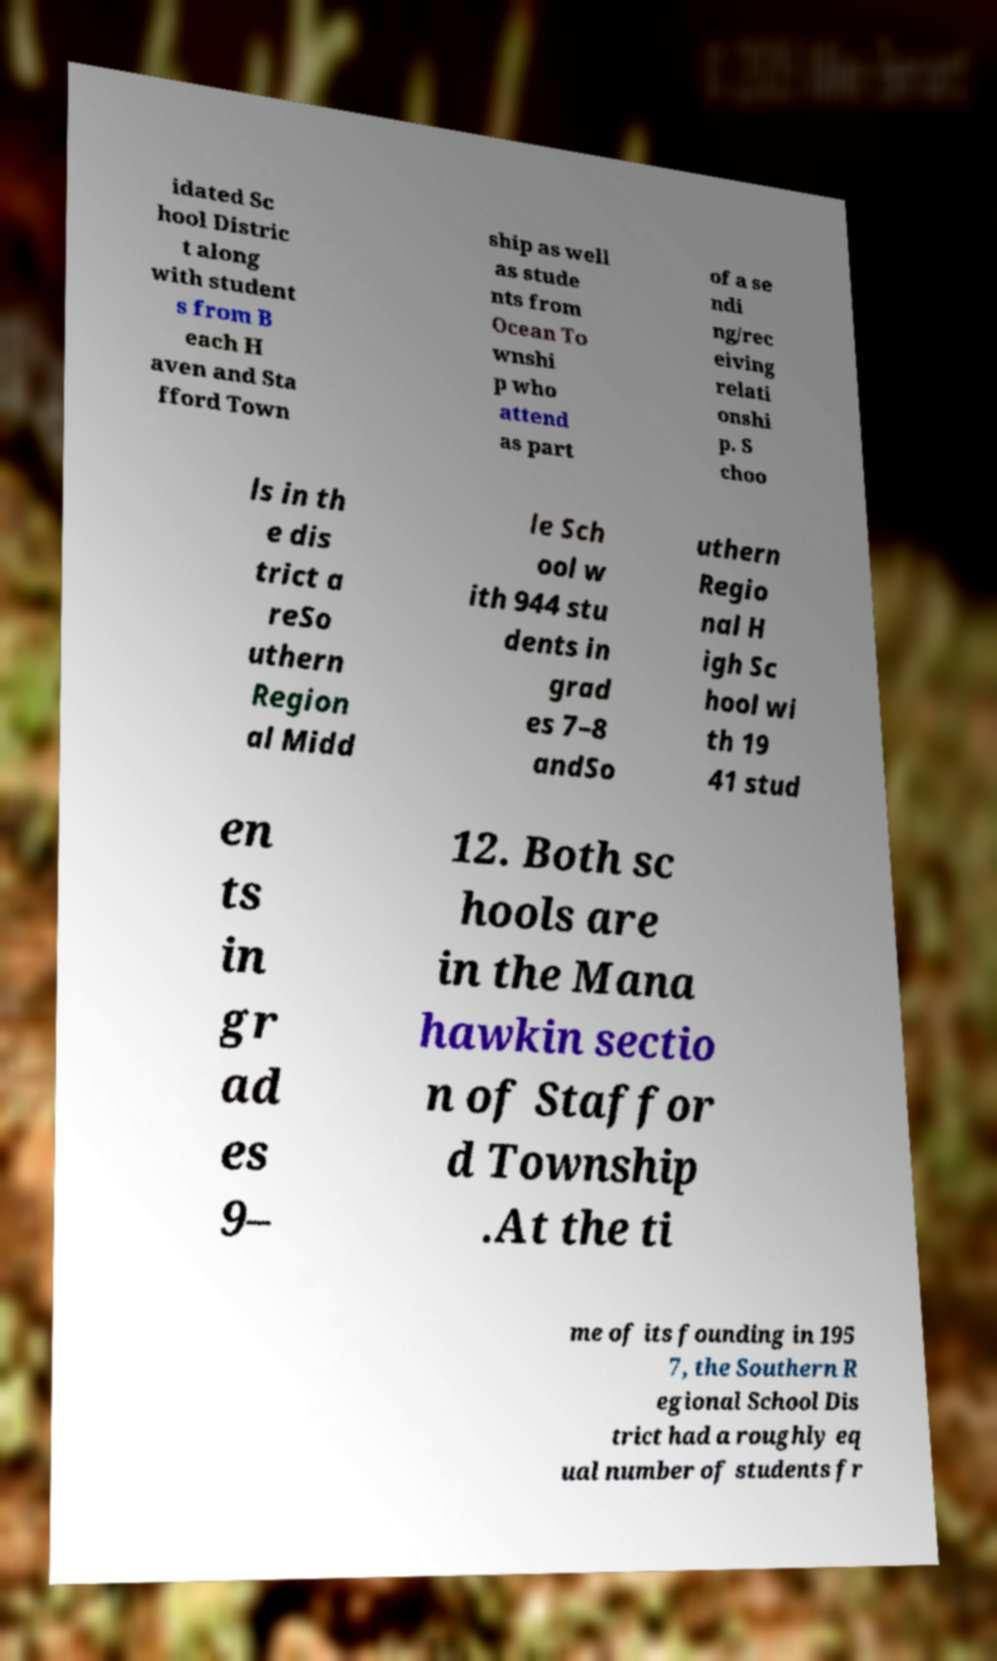Can you accurately transcribe the text from the provided image for me? idated Sc hool Distric t along with student s from B each H aven and Sta fford Town ship as well as stude nts from Ocean To wnshi p who attend as part of a se ndi ng/rec eiving relati onshi p. S choo ls in th e dis trict a reSo uthern Region al Midd le Sch ool w ith 944 stu dents in grad es 7–8 andSo uthern Regio nal H igh Sc hool wi th 19 41 stud en ts in gr ad es 9– 12. Both sc hools are in the Mana hawkin sectio n of Staffor d Township .At the ti me of its founding in 195 7, the Southern R egional School Dis trict had a roughly eq ual number of students fr 